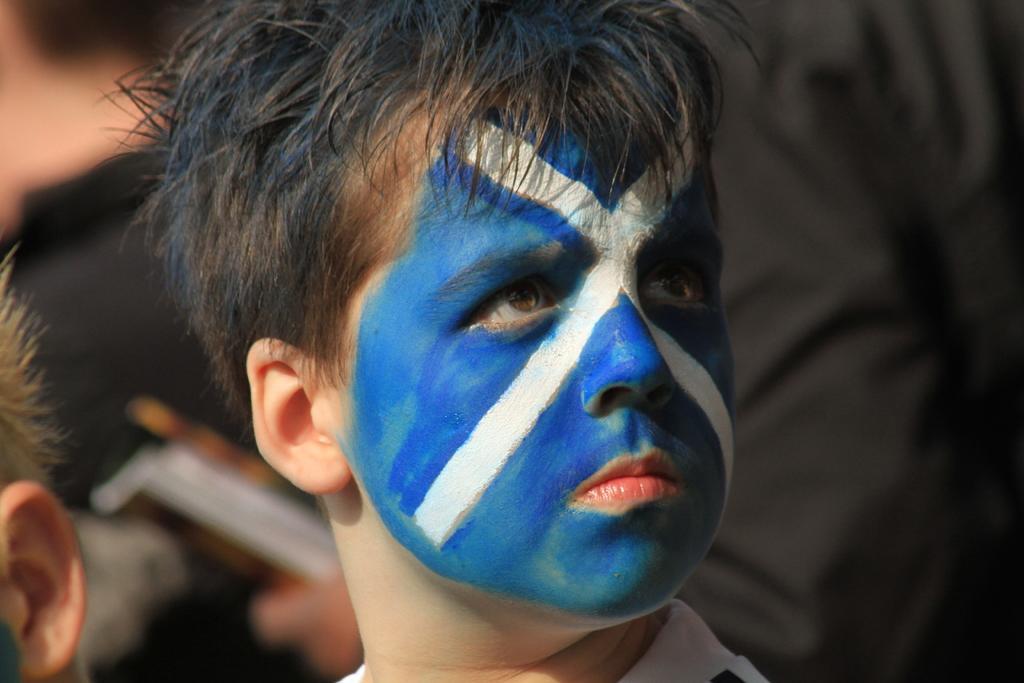In one or two sentences, can you explain what this image depicts? In the picture I can see a child upon whose face I can see the blue and white color paint. The background of the image is slightly blurred, where we can see a few more people. 